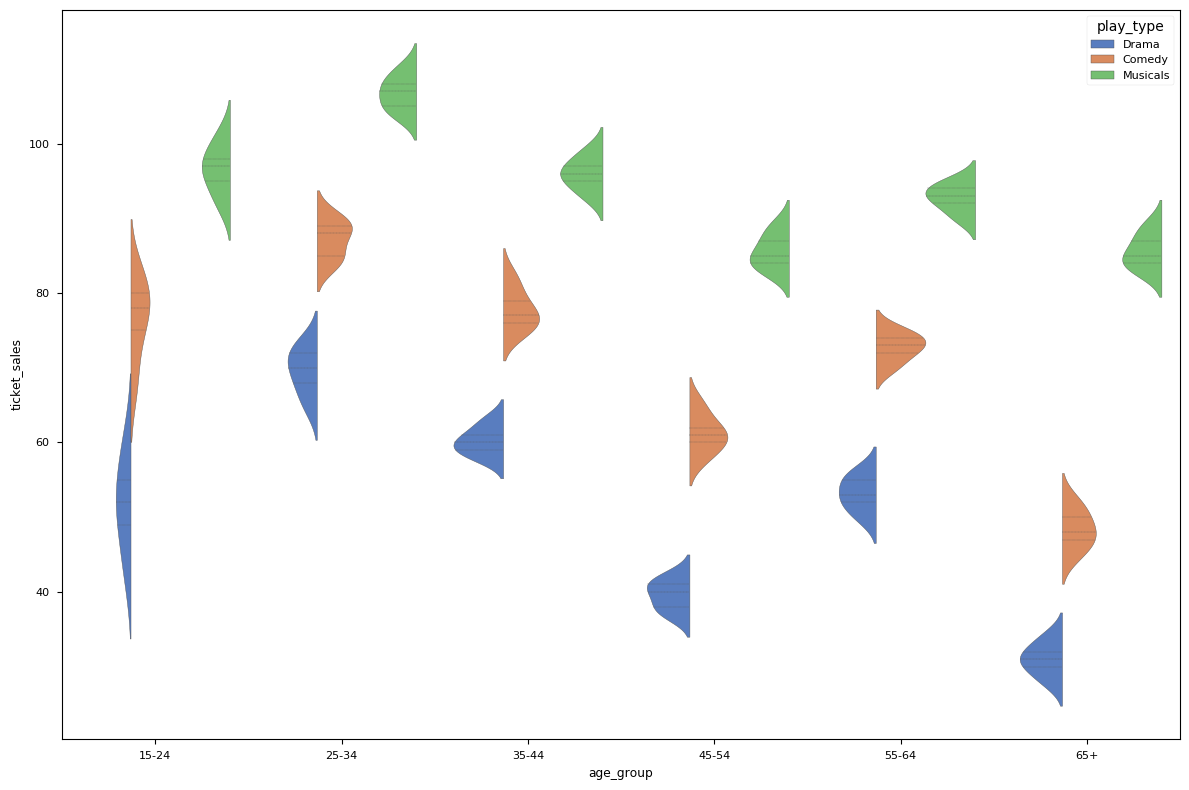Which age group has the highest median ticket sales for musicals? The median ticket sales for musicals by age group 25-34 appears highest, based on the center line of the inner quartiles in the violin plot.
Answer: 25-34 What is the range of ticket sales for comedy plays in the 45-54 age group? To determine the range, find the highest and lowest points of the distribution in the violin plot for comedy plays in the 45-54 age group. The highest is 65 and the lowest is 58. The range is 65-58=7.
Answer: 7 Which play type shows the lowest median ticket sales in the 65+ age group? By examining the central line for each play type within the 65+ age group's violin plots, drama has the lowest central line indicating the lowest median.
Answer: Drama For age group 55-64, which type of play has the widest distribution of ticket sales? The width of the violin plot for each play type in the 55-64 age group indicates the spread. Musicals show the widest distribution, suggesting the most variability in ticket sales.
Answer: Musicals Is the median ticket sales for drama higher in age group 25-34 or 15-24? Compare the central lines (medians) on the violin plots for drama in the 25-34 and 15-24 age groups. The central line is higher for the 25-34 age group.
Answer: 25-34 Compare the interquartile range (IQR) for comedy between the age groups 35-44 and 45-54. Which has a larger IQR? The IQR is the range between the first and third quartiles. For comedy in 35-44, the quartiles are approximately 75 and 82. For 45-54, they are around 58 and 62. The IQR is 82-75=7 for 35-44 and 62-58=4 for 45-54. Thus, 35-44 has a larger IQR.
Answer: 35-44 What is the overall trend in median ticket sales for drama across the different age groups? Observing the central lines (medians) in the violin plots for drama across age groups, the trend shows a peak at 25-34 and a general decline as the age increases beyond that.
Answer: Declining with age Are the ticket sales for musicals typically higher than for dramas across all age groups? Examining the central lines (medians) for musicals and dramas in each age group: musicals consistently show higher median ticket sales compared to dramas.
Answer: Yes Which age group has the narrowest spread of ticket sales for musicals? Look at the width of the violin plot for musicals within each age group; the age group 65+ shows the narrowest spread, indicating less variability.
Answer: 65+ 